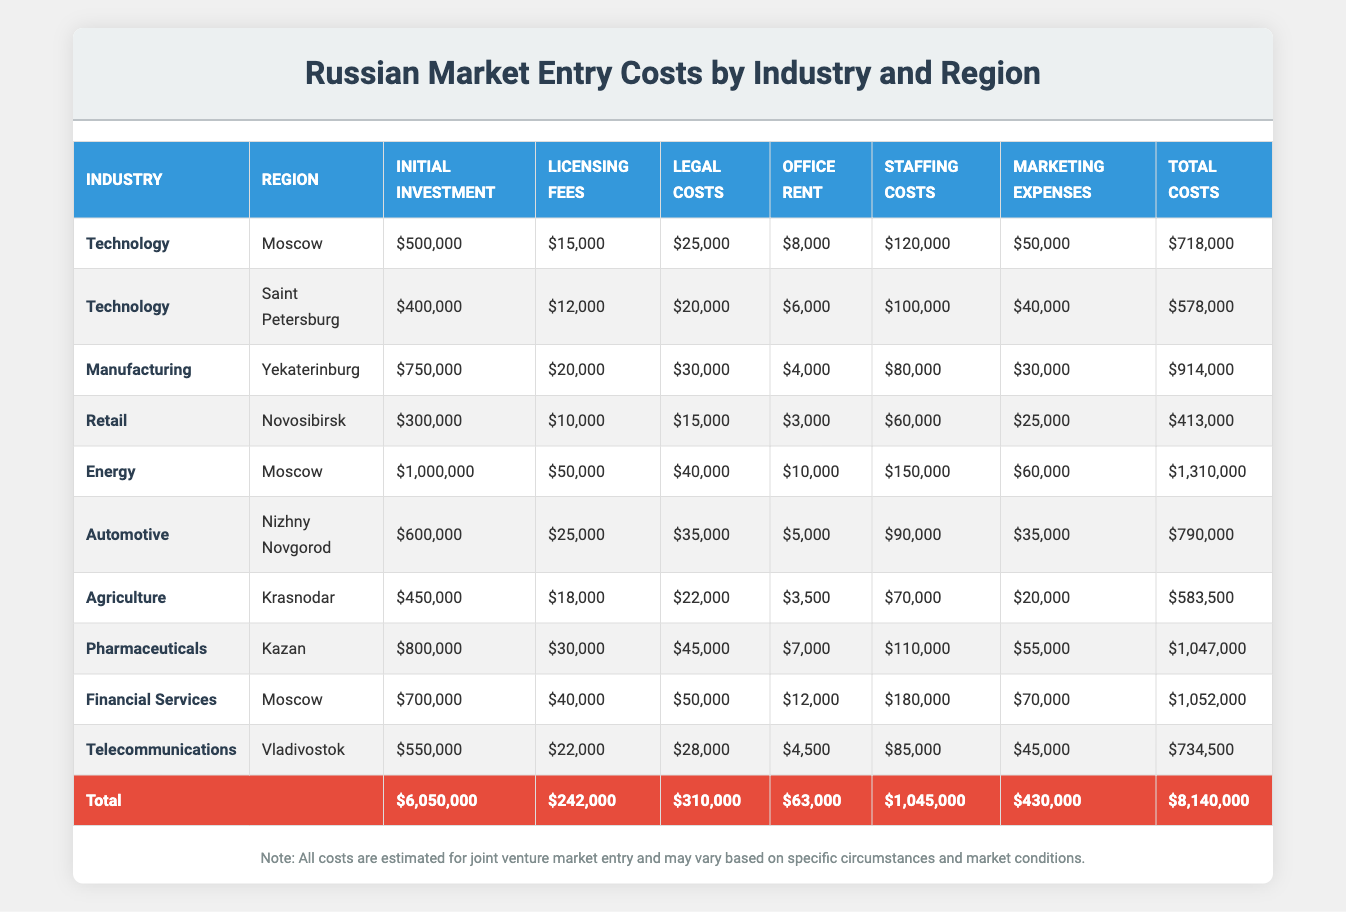What is the total cost associated with entering the retail industry in Novosibirsk? The table shows the total costs associated with the retail industry in Novosibirsk as $413,000.
Answer: $413,000 What is the highest initial investment required for a joint venture in Moscow? The table indicates that the highest initial investment in Moscow is for the energy industry at $1,000,000.
Answer: $1,000,000 Which region requires the least staffing costs for a joint venture, and what is the amount? The least staffing costs are found in Novosibirsk under the retail industry, which is $60,000.
Answer: $60,000 What is the sum of licensing fees across all industries? To find the sum, we add the licensing fees from each industry (15,000 + 12,000 + 20,000 + 10,000 + 50,000 + 25,000 + 18,000 + 30,000 + 40,000 + 22,000 = 242,000). The total licensing fees amount to $242,000.
Answer: $242,000 Is the total cost of entering the pharmaceutical industry in Kazan higher than the total cost of entering the automotive industry in Nizhny Novgorod? The total cost for pharmaceuticals in Kazan is $1,047,000 and for automotive in Nizhny Novgorod, it is $790,000. Since $1,047,000 is greater than $790,000, the statement is true.
Answer: Yes What is the average total cost for all industries listed in Moscow? To calculate the average, we take the total costs for the three industries in Moscow (Technology: 718,000 + Energy: 1,310,000 + Financial Services: 1,052,000 = 3,080,000) and divide it by 3, giving an average of $1,026,667.
Answer: $1,026,667 Which industry requires the highest legal costs among all regions, and what is the value? The highest legal costs are observed in the financial services industry in Moscow at $50,000.
Answer: $50,000 What is the difference in total costs between the technology industry in Saint Petersburg and the energy industry in Moscow? The total cost for technology in Saint Petersburg is $578,000 while for energy in Moscow it is $1,310,000. The difference is $1,310,000 - $578,000 = $732,000.
Answer: $732,000 Is the initial investment for the agriculture industry in Krasnodar lower than the initial investment for the technology industry in Moscow? The initial investment for agriculture in Krasnodar is $450,000, while for technology in Moscow it is $500,000. Since $450,000 is less than $500,000, the statement is true.
Answer: Yes 